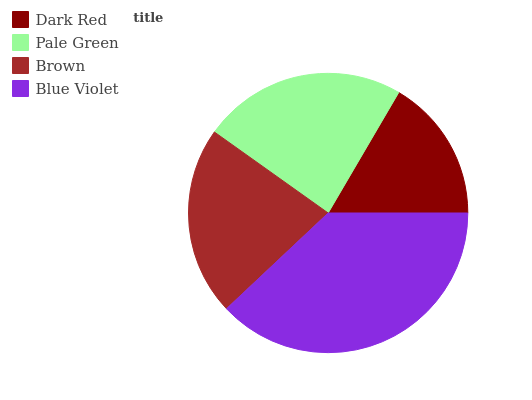Is Dark Red the minimum?
Answer yes or no. Yes. Is Blue Violet the maximum?
Answer yes or no. Yes. Is Pale Green the minimum?
Answer yes or no. No. Is Pale Green the maximum?
Answer yes or no. No. Is Pale Green greater than Dark Red?
Answer yes or no. Yes. Is Dark Red less than Pale Green?
Answer yes or no. Yes. Is Dark Red greater than Pale Green?
Answer yes or no. No. Is Pale Green less than Dark Red?
Answer yes or no. No. Is Pale Green the high median?
Answer yes or no. Yes. Is Brown the low median?
Answer yes or no. Yes. Is Dark Red the high median?
Answer yes or no. No. Is Pale Green the low median?
Answer yes or no. No. 